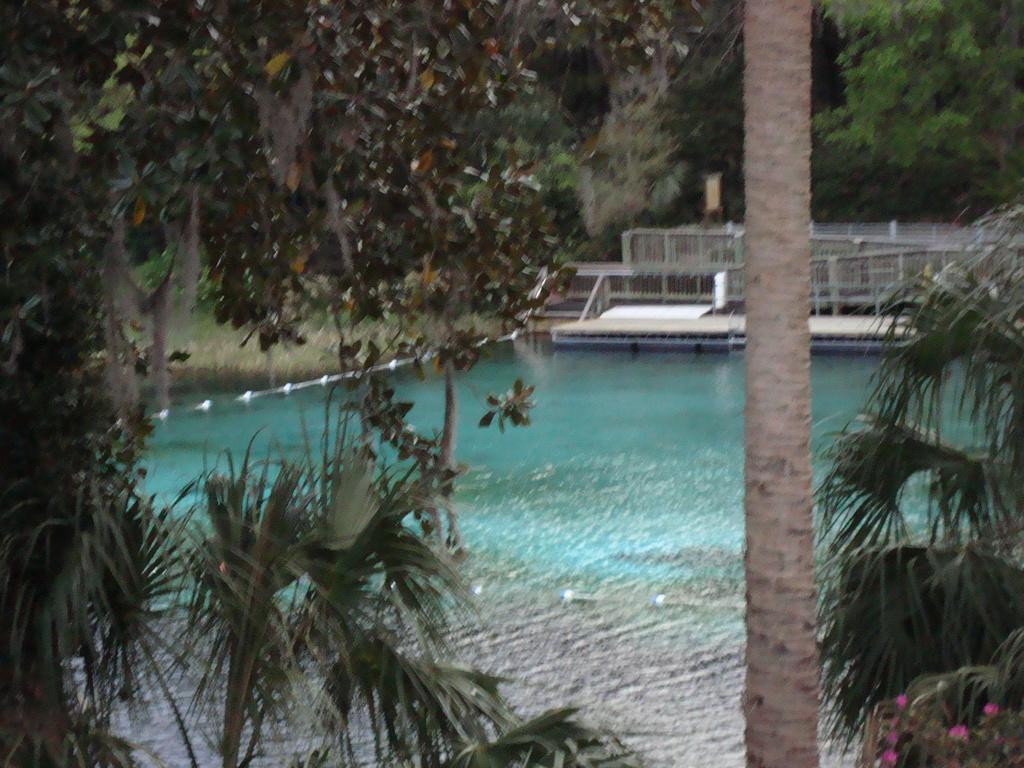Can you describe this image briefly? In this picture we can see water, here we can see a platform, fence, flowers and some objects and in the background we can see trees. 